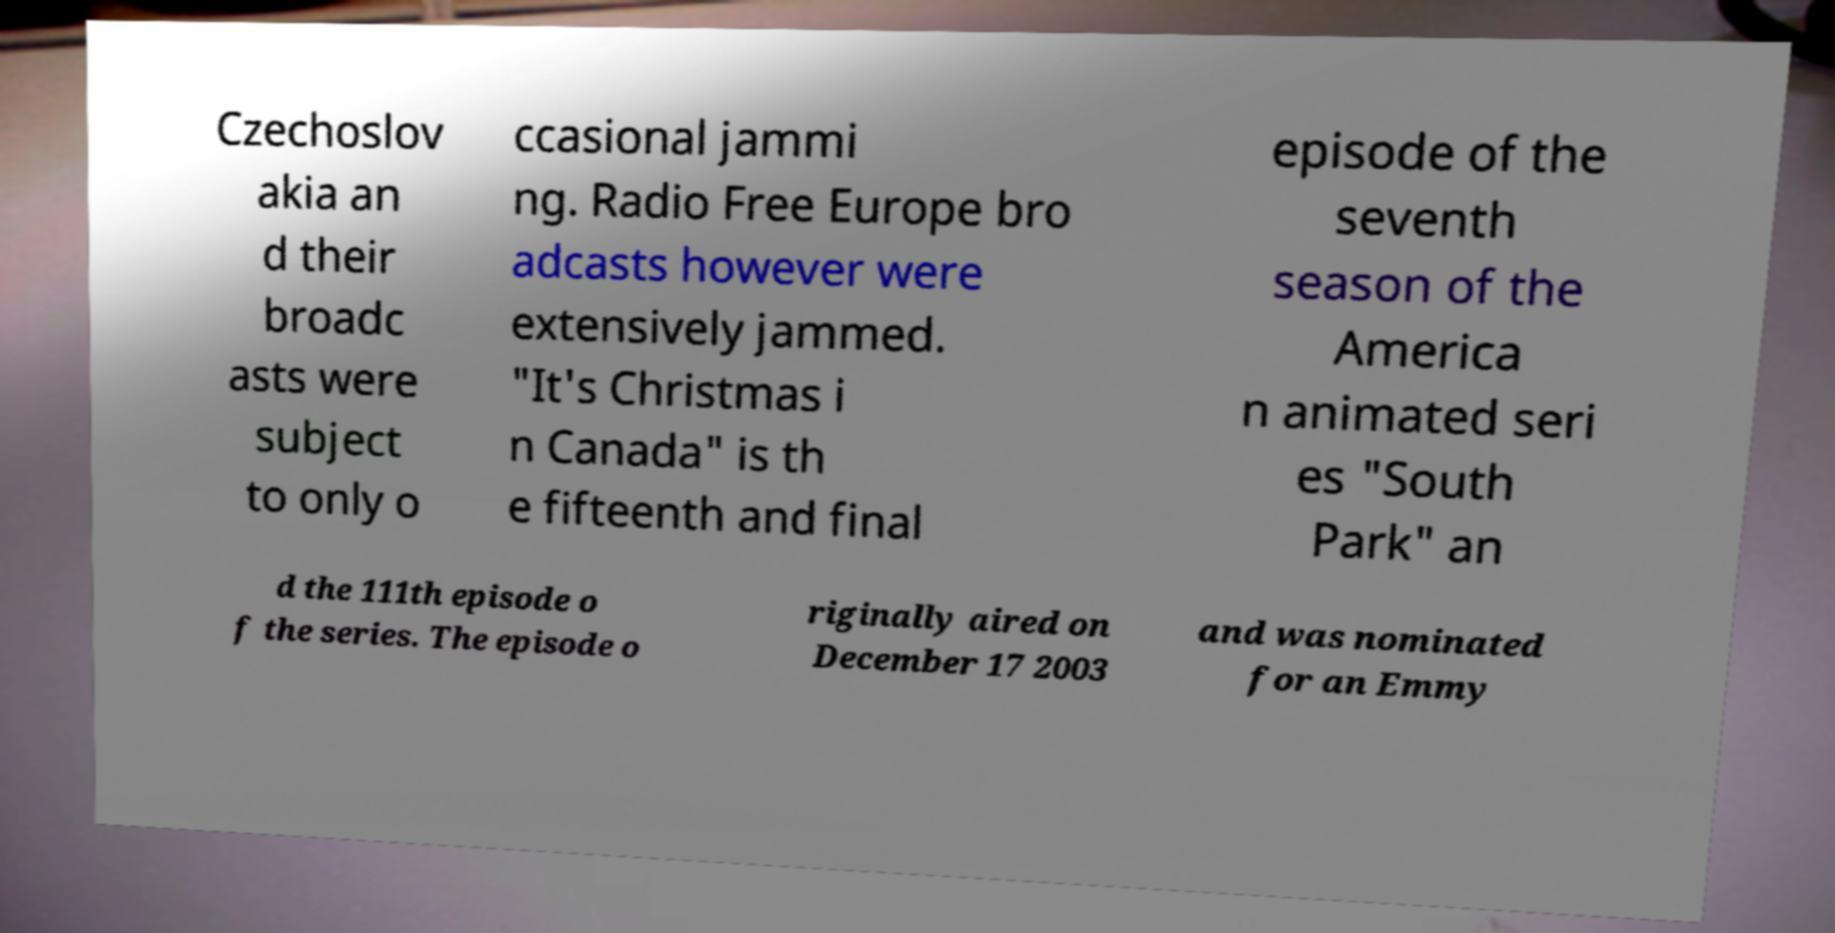Please read and relay the text visible in this image. What does it say? Czechoslov akia an d their broadc asts were subject to only o ccasional jammi ng. Radio Free Europe bro adcasts however were extensively jammed. "It's Christmas i n Canada" is th e fifteenth and final episode of the seventh season of the America n animated seri es "South Park" an d the 111th episode o f the series. The episode o riginally aired on December 17 2003 and was nominated for an Emmy 